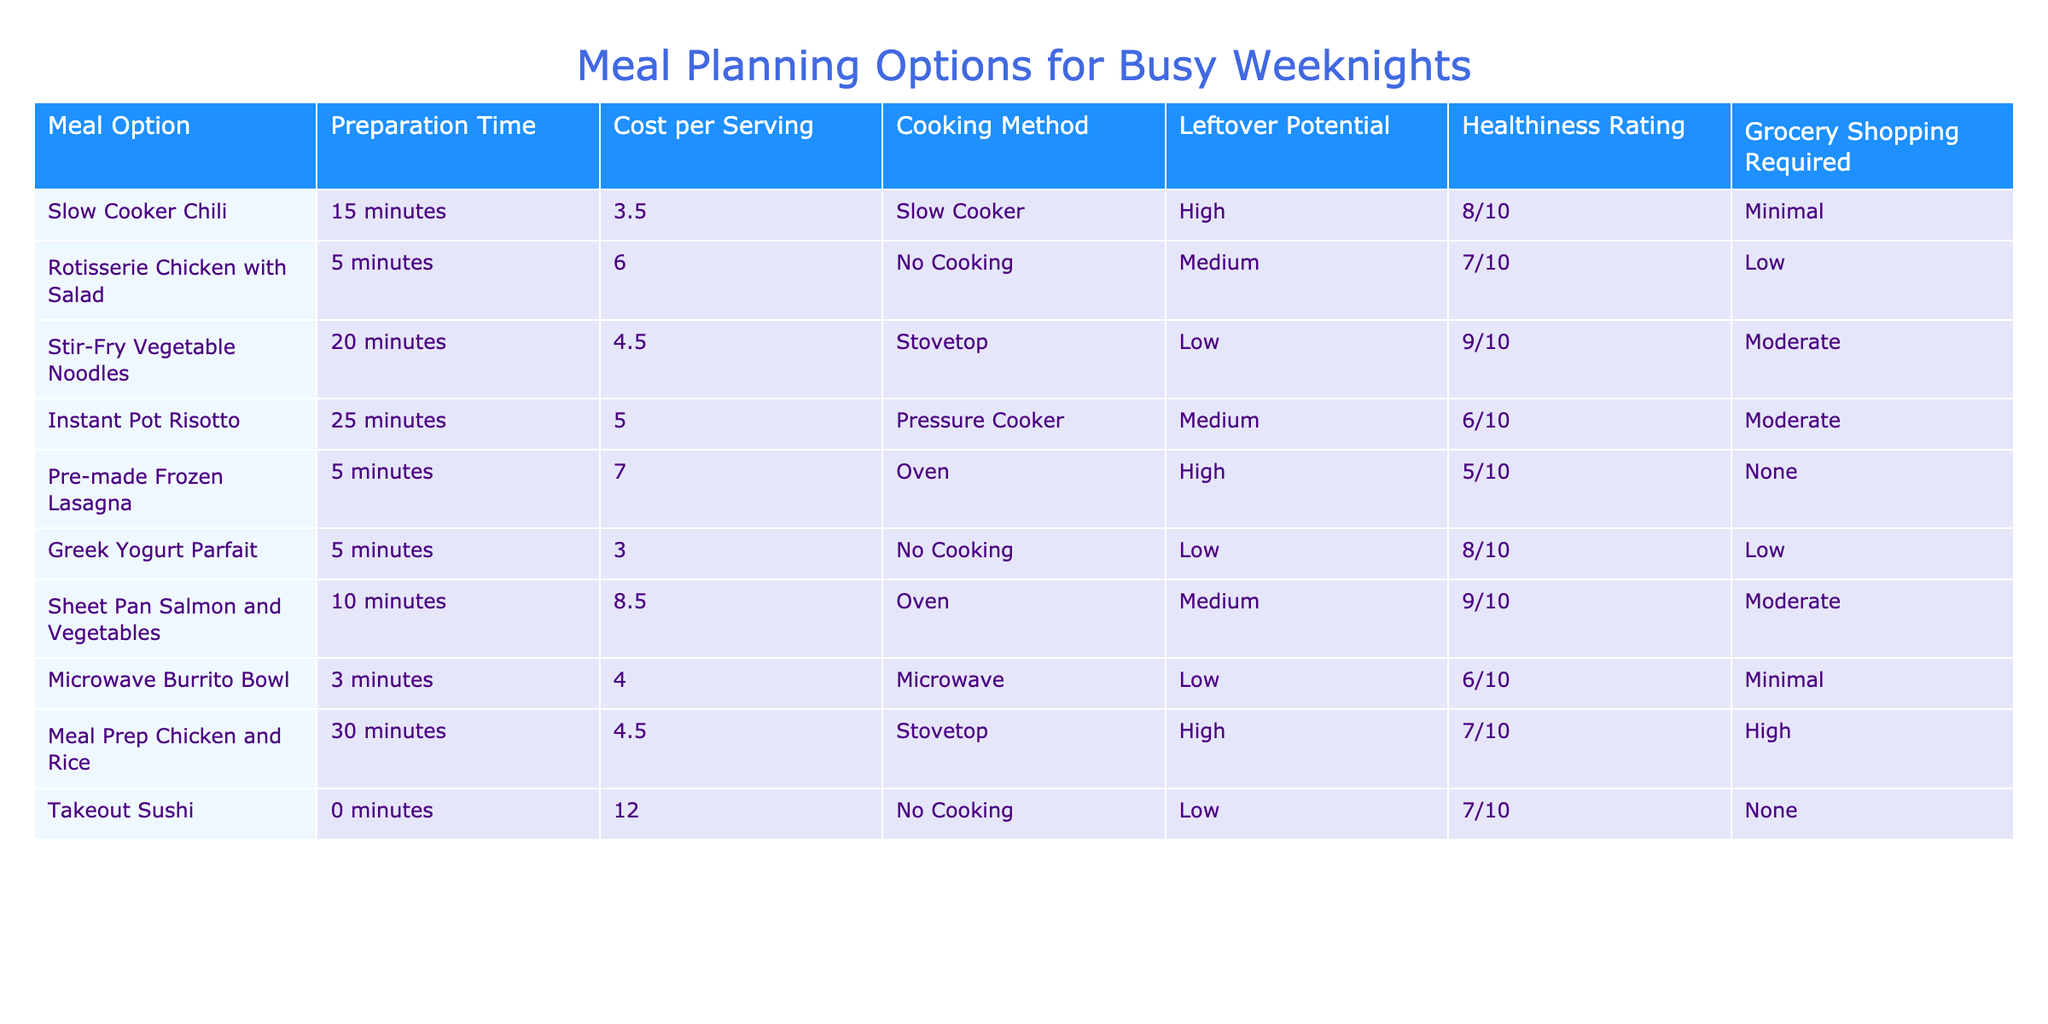What is the preparation time for Instant Pot Risotto? The table states that Instant Pot Risotto has a preparation time of 25 minutes.
Answer: 25 minutes Which meal option has the highest healthiness rating? By comparing the healthiness ratings in the table, Slow Cooker Chili, Stir-Fry Vegetable Noodles, and Greek Yogurt Parfait all have high ratings, but Stir-Fry Vegetable Noodles has the highest rating of 9/10.
Answer: Stir-Fry Vegetable Noodles (9/10) Is the cost per serving for Rotisserie Chicken with Salad more than 5 dollars? The table indicates that the cost per serving for Rotisserie Chicken with Salad is 6.00 dollars. Since 6.00 is greater than 5, the answer is yes.
Answer: Yes What is the leftover potential for Microwave Burrito Bowl? The table shows that the leftover potential for Microwave Burrito Bowl is low.
Answer: Low Calculate the average cost per serving of all meal options listed. To find the average cost, we sum the cost per serving of each meal option: 3.50 + 6.00 + 4.50 + 5.00 + 7.00 + 3.00 + 8.50 + 4.00 + 4.50 + 12.00 = 58.00. There are 10 meal options, so the average cost per serving is 58.00 / 10 = 5.80.
Answer: 5.80 Which cooking method has the most meal options associated with it? Analyzing the cooking methods, 'No Cooking' has 2 meal options (Rotisserie Chicken with Salad and Takeout Sushi) while others have either 1 or 2. Since there isn't a clear single most common method, we find that 'No Cooking' and 'Slow Cooker' both feature multiple options, making it slightly more common.
Answer: No Cooking (2 options) Is there any meal option that requires no grocery shopping? The table shows that Pre-made Frozen Lasagna and Takeout Sushi do not require any grocery shopping. Thus, there are meal options that meet this criterion.
Answer: Yes How much time in total is required to prepare Meal Prep Chicken and Rice and Instant Pot Risotto? The preparation time for Meal Prep Chicken and Rice is 30 minutes while that for Instant Pot Risotto is 25 minutes. Therefore, the total preparation time is 30 + 25 = 55 minutes.
Answer: 55 minutes Which meal has a moderate healthiness rating and high leftover potential? The table indicates that Meal Prep Chicken and Rice is noted for being moderate in healthiness with a high leftover potential; it has a healthiness rating of 7/10, thereby meeting both criteria.
Answer: Meal Prep Chicken and Rice 